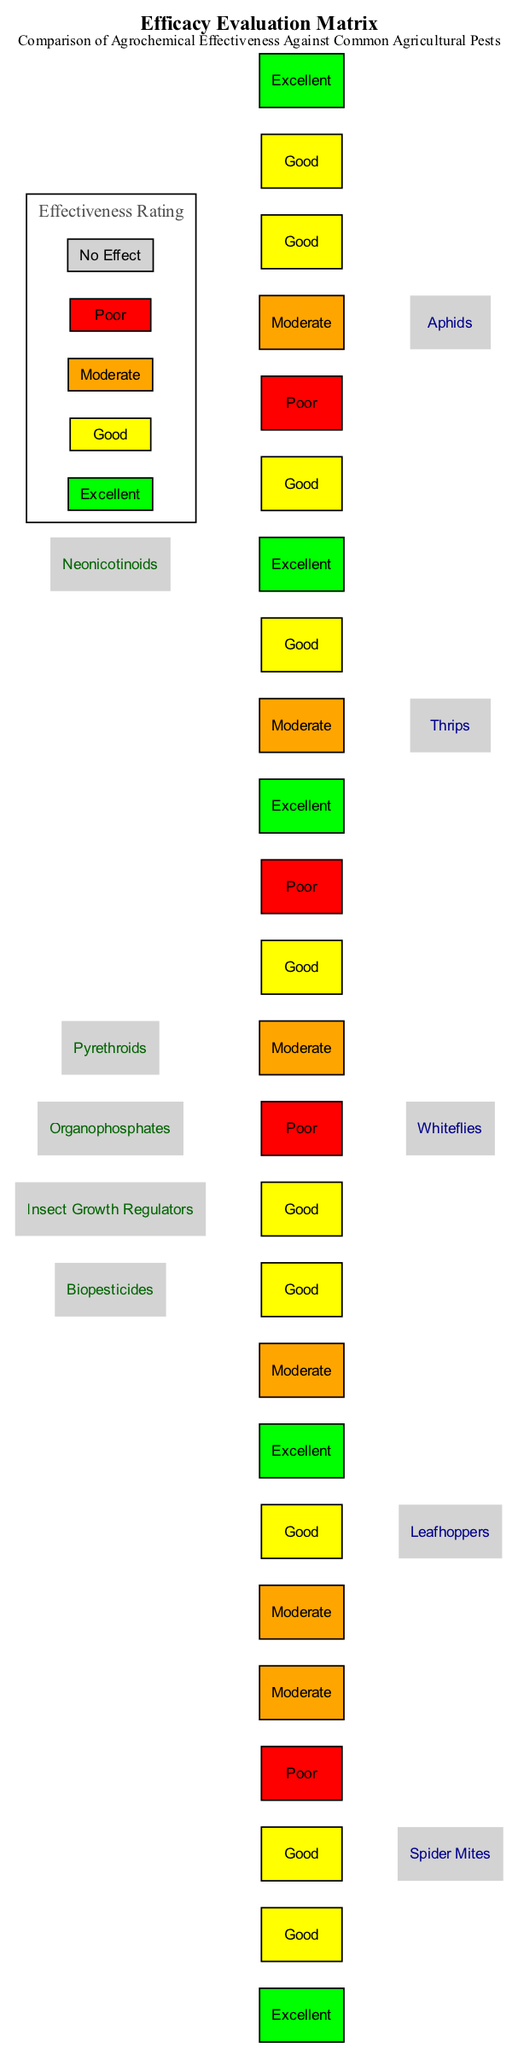What is the effectiveness rating of Neonicotinoids against Aphids? The diagram indicates that Neonicotinoids have an "Excellent" effectiveness rating against Aphids, which is represented in the matrix.
Answer: Excellent Which agrochemical is rated "Moderate" against Spider Mites? Looking at the matrix, Organophosphates and Biopesticides both have a "Moderate" rating against Spider Mites.
Answer: Organophosphates, Biopesticides How many pests are compared in the effectiveness evaluation? The diagram lists five pests: Aphids, Leafhoppers, Spider Mites, Thrips, and Whiteflies, which totals five pests.
Answer: 5 What color represents a "Poor" effectiveness rating in the diagram? The effectiveness rating of "Poor" is visually represented in red within the matrix chart.
Answer: Red Which agrochemical has the best overall effectiveness ratings against the listed pests? By analyzing the ratings for each agrochemical against all pests, Neonicotinoids show the highest count of "Excellent" and "Good" ratings, making it the most effective overall.
Answer: Neonicotinoids How does the effectiveness of Insect Growth Regulators against Thrips compare to their effectiveness against Whiteflies? Insect Growth Regulators are rated "Excellent" against Thrips and "Good" against Whiteflies, indicating higher effectiveness against Thrips.
Answer: More effective against Thrips What is the lowest effectiveness rating given to any agrochemical against Leafhoppers? In the matrix, Insect Growth Regulators have a "Moderate" rating against Leafhoppers, which is the lowest rating among the other agrochemicals for that pest.
Answer: Moderate Is there any agrochemical listed that has "No Effect" against any pest? The matrix does not show any agrochemical with a "No Effect" rating against any pest, indicating that all have some level of effectiveness.
Answer: No Which effectiveness rating is represented by the color yellow? The color yellow in the diagram signifies a "Good" effectiveness rating for the agrochemicals against the pests evaluated.
Answer: Good 